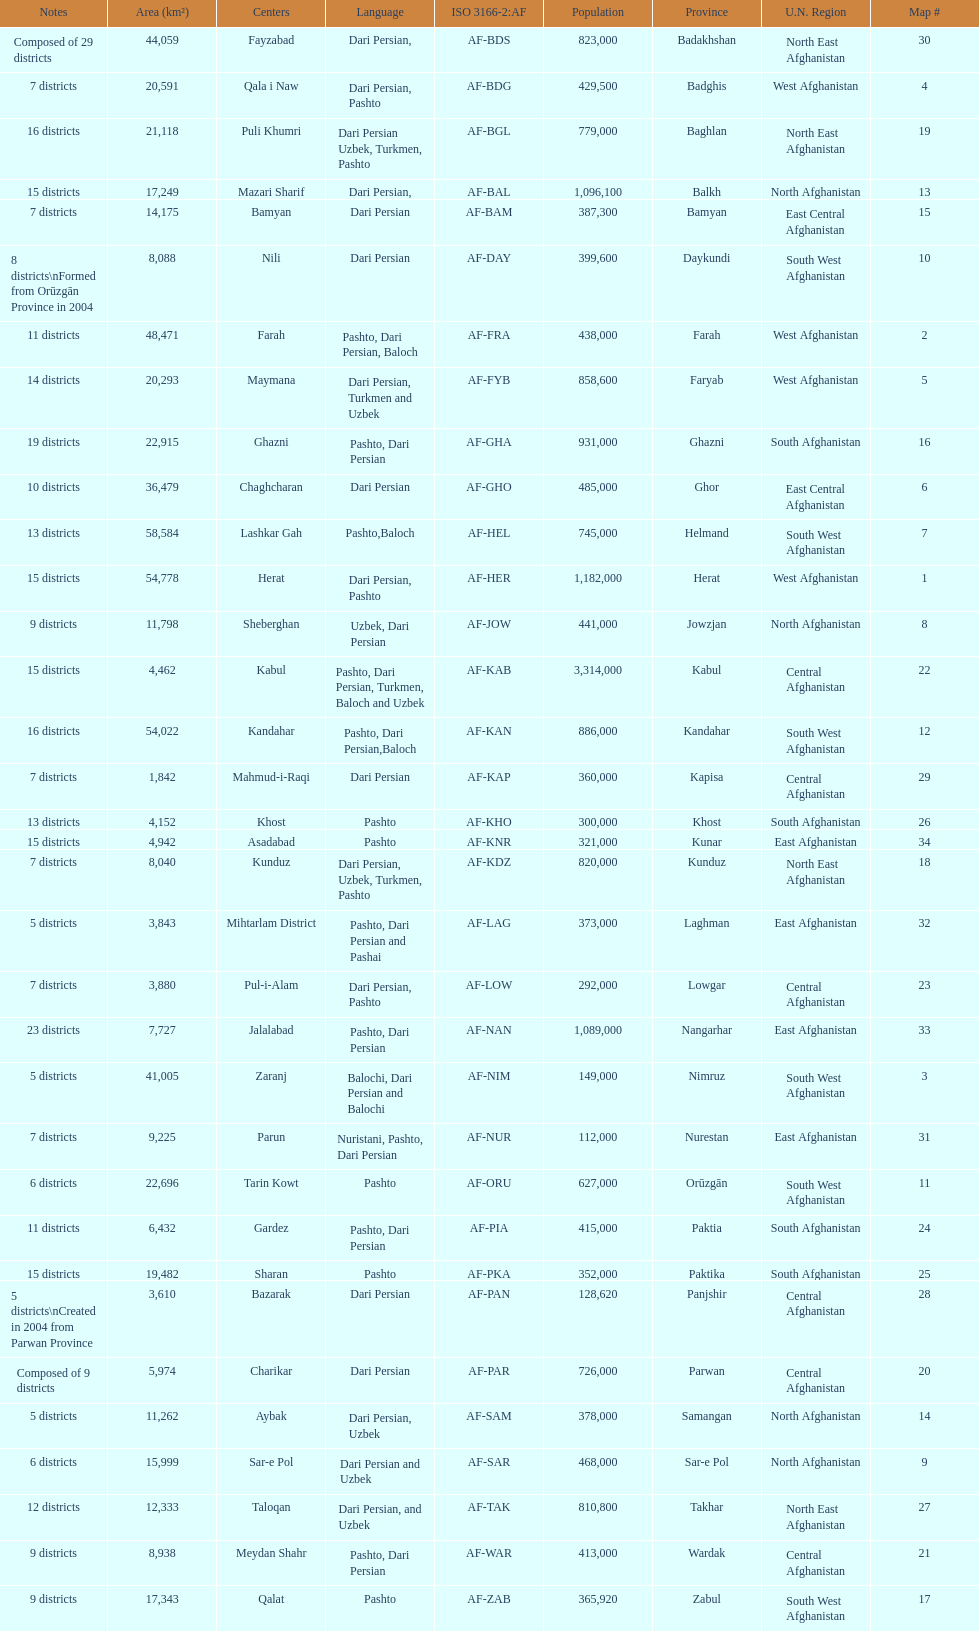Herat has a population of 1,182,000, can you list their languages Dari Persian, Pashto. 